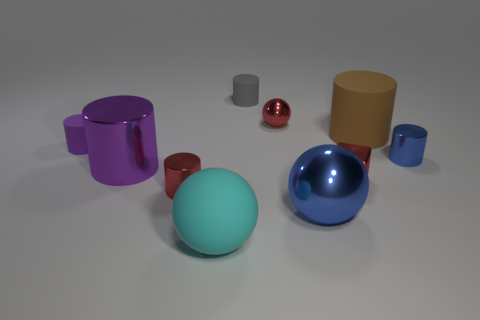What size is the blue object behind the large sphere right of the large matte object that is to the left of the small gray cylinder?
Ensure brevity in your answer.  Small. What number of blue cylinders are the same size as the purple matte cylinder?
Ensure brevity in your answer.  1. How many objects are gray objects or big cyan spheres left of the red metal ball?
Keep it short and to the point. 2. The purple shiny thing is what shape?
Provide a short and direct response. Cylinder. Is the small ball the same color as the small shiny cube?
Offer a very short reply. Yes. What color is the other rubber thing that is the same size as the gray rubber thing?
Your answer should be very brief. Purple. How many gray objects are either small metal objects or tiny matte objects?
Provide a succinct answer. 1. Is the number of big cyan rubber balls greater than the number of large blue shiny cylinders?
Your answer should be very brief. Yes. Is the size of the ball behind the large blue metallic sphere the same as the red shiny object that is in front of the cube?
Provide a succinct answer. Yes. There is a large cylinder that is to the left of the ball that is on the left side of the tiny matte object behind the big matte cylinder; what is its color?
Offer a terse response. Purple. 